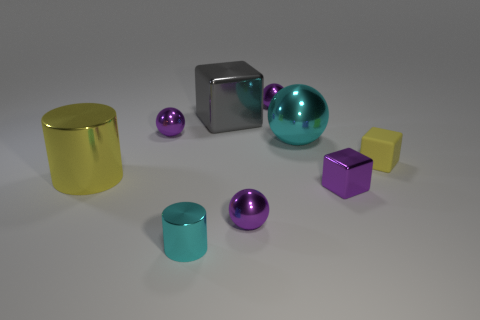What color is the tiny metallic thing to the right of the cyan sphere that is behind the shiny object that is right of the cyan sphere? purple 